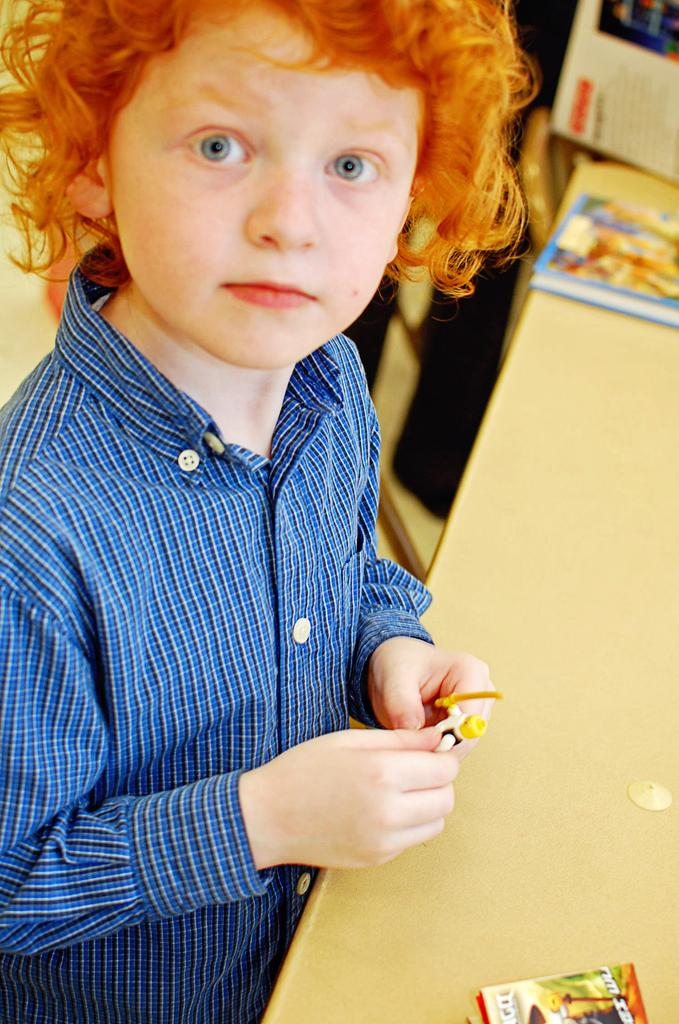Who is the main subject in the image? There is a boy in the image. What is the boy holding in the image? The boy is holding a toy. What is located in front of the boy? There is a table in front of the boy. What items can be seen on the table? There are books on the table. Can you describe the background of the image? The background of the image is blurred. What type of leaf can be seen on the boy's head in the image? There is no leaf present on the boy's head in the image. 